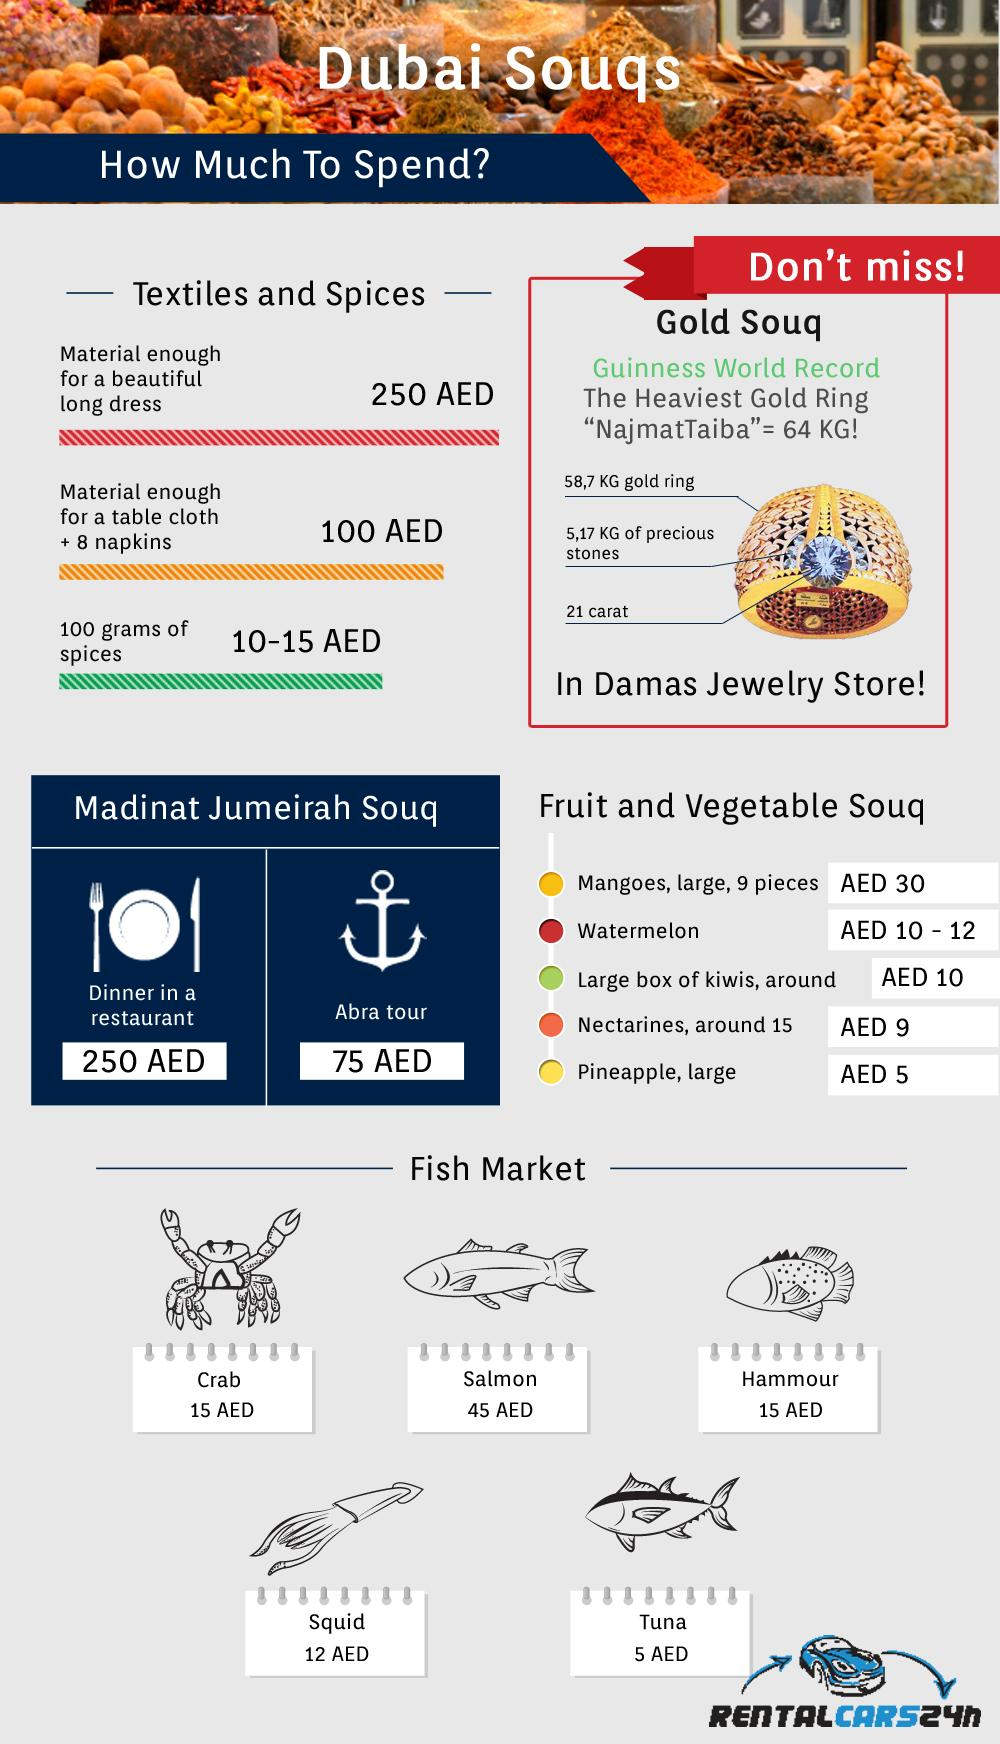Indicate a few pertinent items in this graphic. The cost of Hammour in the fish market at Dubai Souq is 15 AED. NajmatTaiba," the heaviest gold ring, contains a significant quantity of precious stones, weighing 5.17 kilograms. At the Dubai souq fish market, salmon is the fish that commands the highest price. In Dubai, a dinner at a restaurant in Madinat Jumeirah Souq typically costs around 250 AED. The cost for an Abra tour at Madinat Jumeirah Souq in Dubai is 75 AED. 